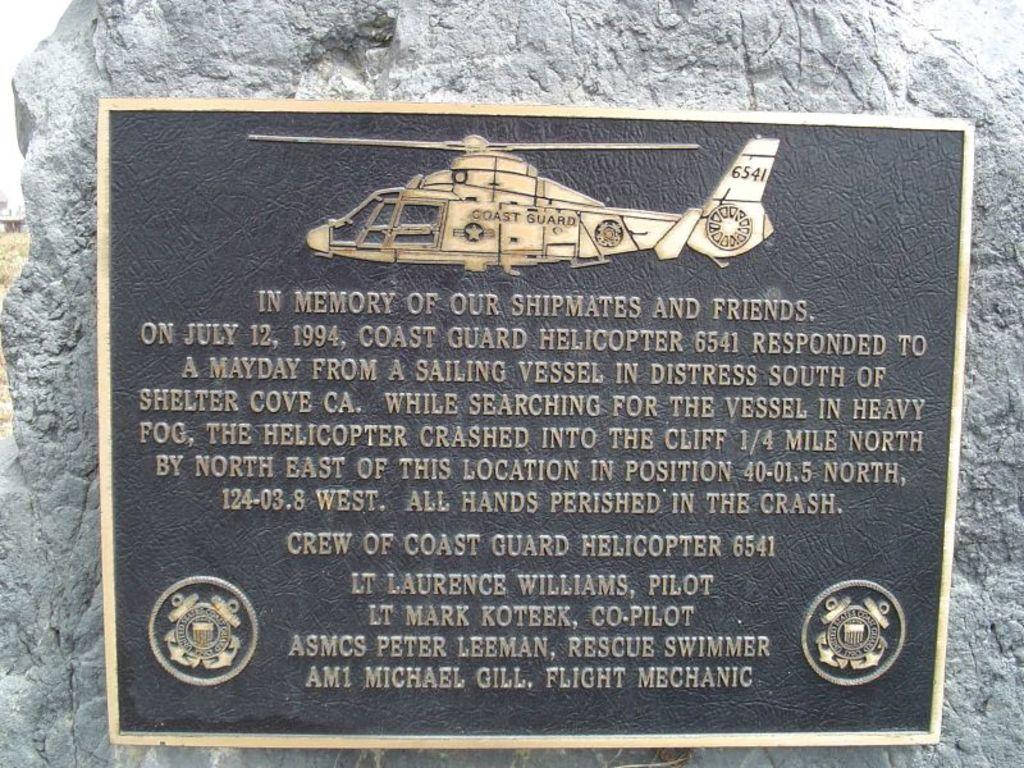<image>
Give a short and clear explanation of the subsequent image. A plaque has a engraving of a helicopter and is "In Memory of Our Shipmates and Friends" 